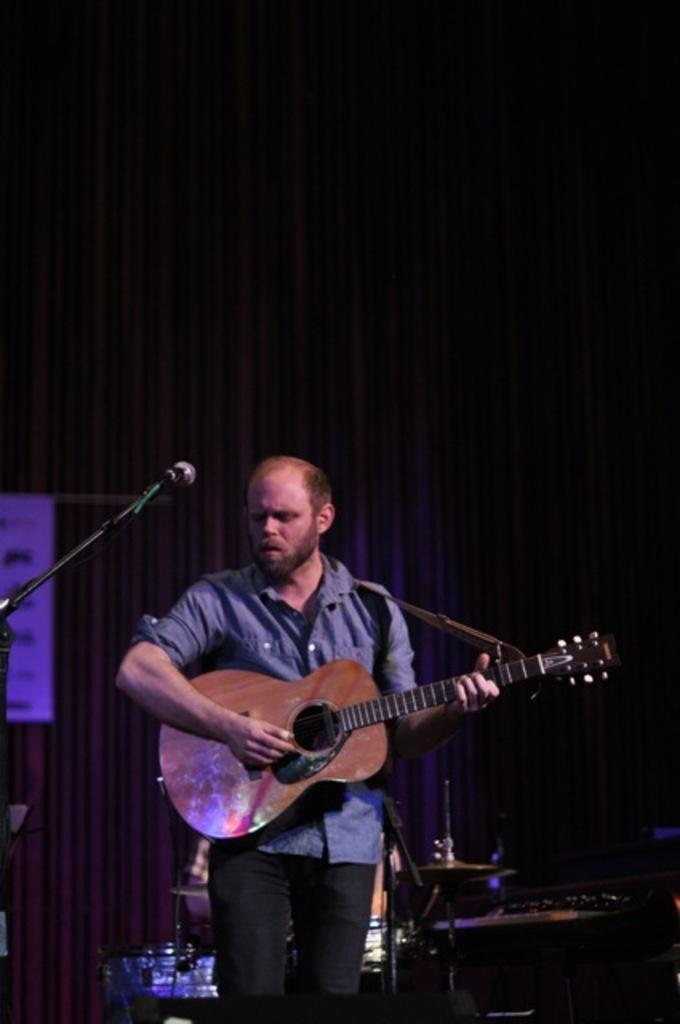What is the man in the image doing? The man is playing a guitar. What object is present in the image that might be used for amplifying sound? There is a microphone in the image. What type of sign is the man holding in the image? There is no sign present in the image; the man is playing a guitar. What type of agreement is the man discussing with the audience in the image? There is no discussion or agreement present in the image; the man is playing a guitar. 